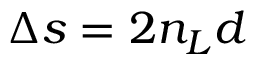Convert formula to latex. <formula><loc_0><loc_0><loc_500><loc_500>\Delta s = 2 n _ { L } d</formula> 